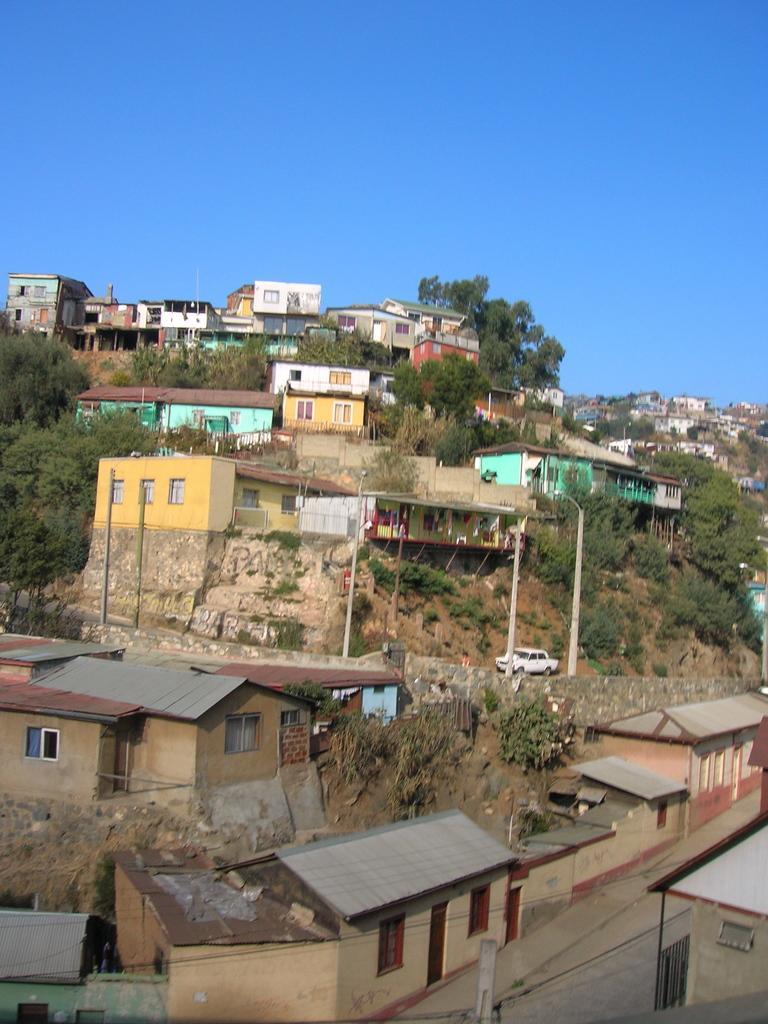Describe this image in one or two sentences. In this image we can see a two hills. There are many houses and trees in the image. There is a clear and blue sky in the image. There is a car, an electrical pole and few cables connected to it. 